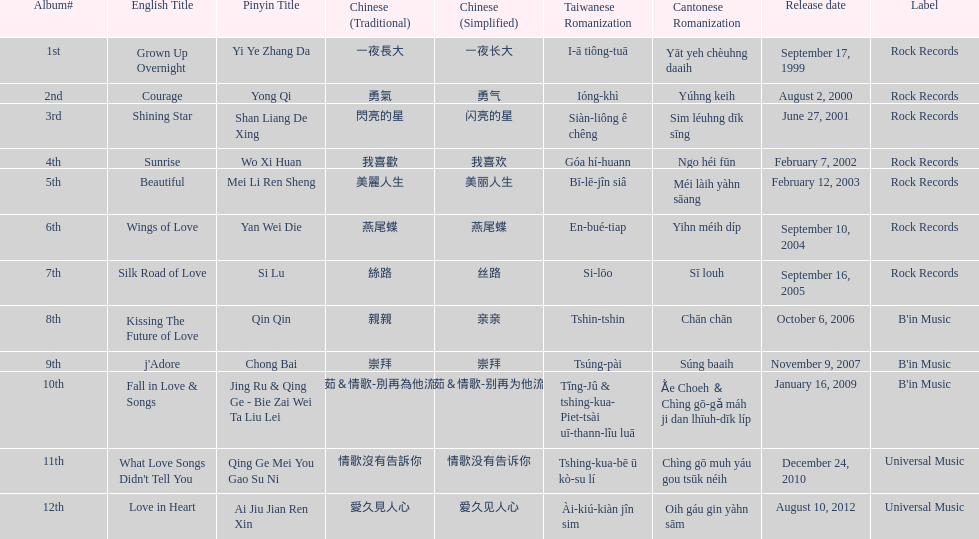What is the number of songs on rock records? 7. 